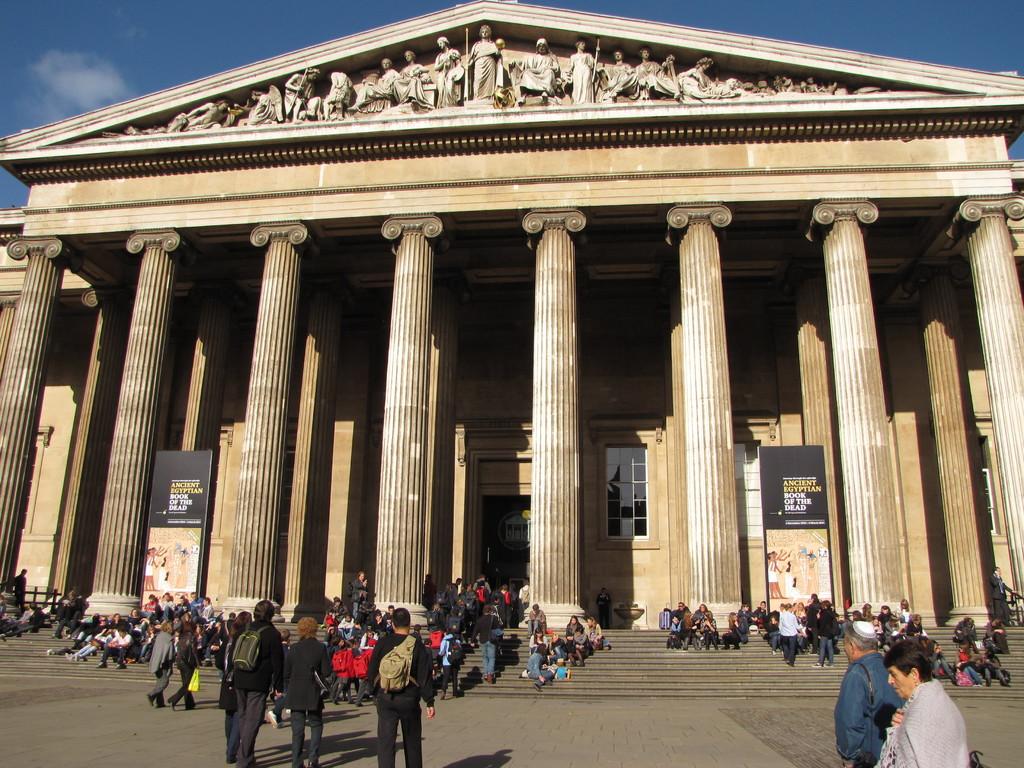What does the black sign say in front of the pillar?
Ensure brevity in your answer.  Ancient egyptian book of the dead. 